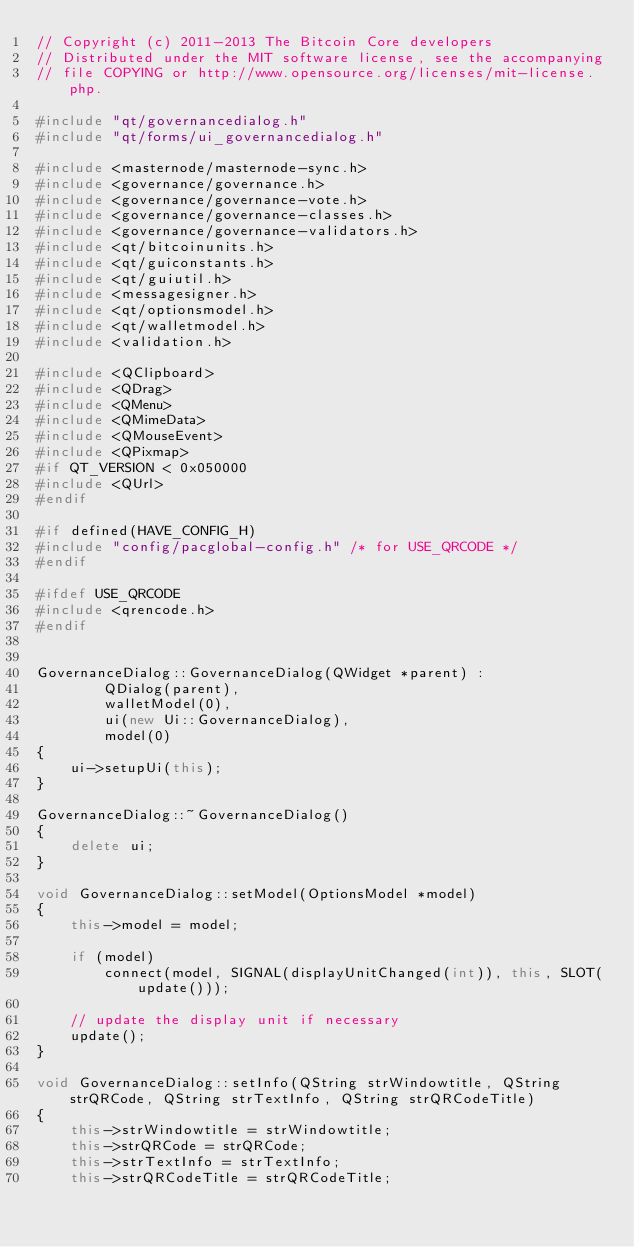Convert code to text. <code><loc_0><loc_0><loc_500><loc_500><_C++_>// Copyright (c) 2011-2013 The Bitcoin Core developers
// Distributed under the MIT software license, see the accompanying
// file COPYING or http://www.opensource.org/licenses/mit-license.php.

#include "qt/governancedialog.h"
#include "qt/forms/ui_governancedialog.h"

#include <masternode/masternode-sync.h>
#include <governance/governance.h>
#include <governance/governance-vote.h>
#include <governance/governance-classes.h>
#include <governance/governance-validators.h>
#include <qt/bitcoinunits.h>
#include <qt/guiconstants.h>
#include <qt/guiutil.h>
#include <messagesigner.h>
#include <qt/optionsmodel.h>
#include <qt/walletmodel.h>
#include <validation.h>

#include <QClipboard>
#include <QDrag>
#include <QMenu>
#include <QMimeData>
#include <QMouseEvent>
#include <QPixmap>
#if QT_VERSION < 0x050000
#include <QUrl>
#endif

#if defined(HAVE_CONFIG_H)
#include "config/pacglobal-config.h" /* for USE_QRCODE */
#endif

#ifdef USE_QRCODE
#include <qrencode.h>
#endif


GovernanceDialog::GovernanceDialog(QWidget *parent) :
        QDialog(parent),
        walletModel(0),
        ui(new Ui::GovernanceDialog),
        model(0)
{
    ui->setupUi(this);
}

GovernanceDialog::~GovernanceDialog()
{
    delete ui;
}

void GovernanceDialog::setModel(OptionsModel *model)
{
    this->model = model;

    if (model)
        connect(model, SIGNAL(displayUnitChanged(int)), this, SLOT(update()));

    // update the display unit if necessary
    update();
}

void GovernanceDialog::setInfo(QString strWindowtitle, QString strQRCode, QString strTextInfo, QString strQRCodeTitle)
{
    this->strWindowtitle = strWindowtitle;
    this->strQRCode = strQRCode;
    this->strTextInfo = strTextInfo;
    this->strQRCodeTitle = strQRCodeTitle;</code> 